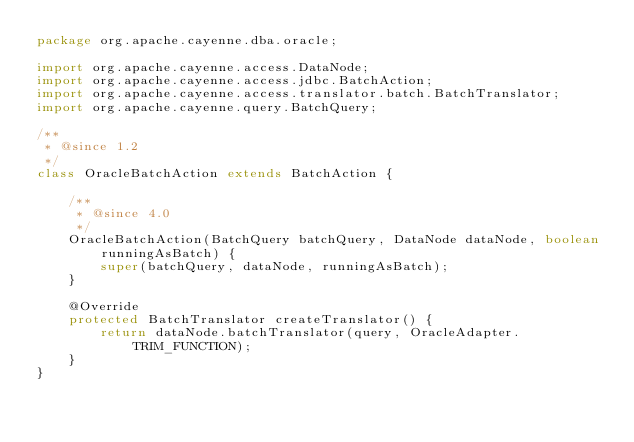Convert code to text. <code><loc_0><loc_0><loc_500><loc_500><_Java_>package org.apache.cayenne.dba.oracle;

import org.apache.cayenne.access.DataNode;
import org.apache.cayenne.access.jdbc.BatchAction;
import org.apache.cayenne.access.translator.batch.BatchTranslator;
import org.apache.cayenne.query.BatchQuery;

/**
 * @since 1.2
 */
class OracleBatchAction extends BatchAction {

    /**
     * @since 4.0
     */
    OracleBatchAction(BatchQuery batchQuery, DataNode dataNode, boolean runningAsBatch) {
        super(batchQuery, dataNode, runningAsBatch);
    }

    @Override
    protected BatchTranslator createTranslator() {
        return dataNode.batchTranslator(query, OracleAdapter.TRIM_FUNCTION);
    }
}
</code> 